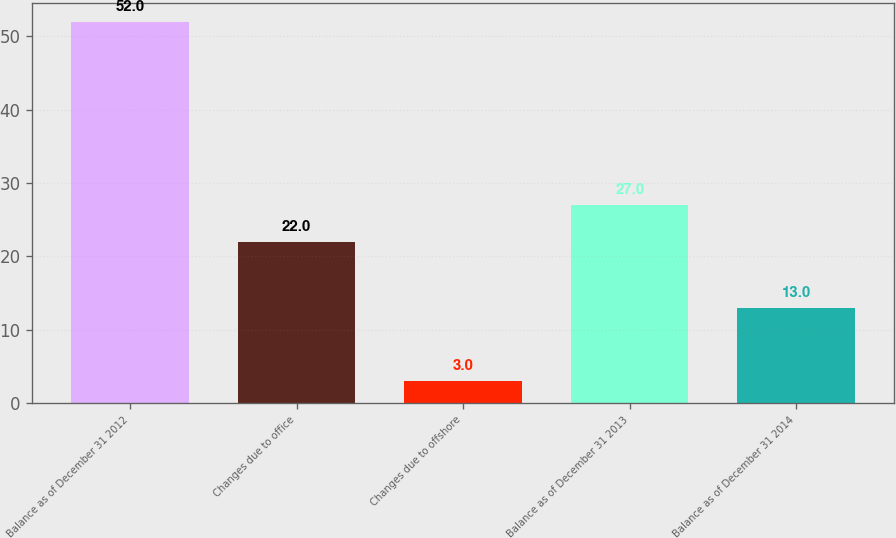<chart> <loc_0><loc_0><loc_500><loc_500><bar_chart><fcel>Balance as of December 31 2012<fcel>Changes due to office<fcel>Changes due to offshore<fcel>Balance as of December 31 2013<fcel>Balance as of December 31 2014<nl><fcel>52<fcel>22<fcel>3<fcel>27<fcel>13<nl></chart> 